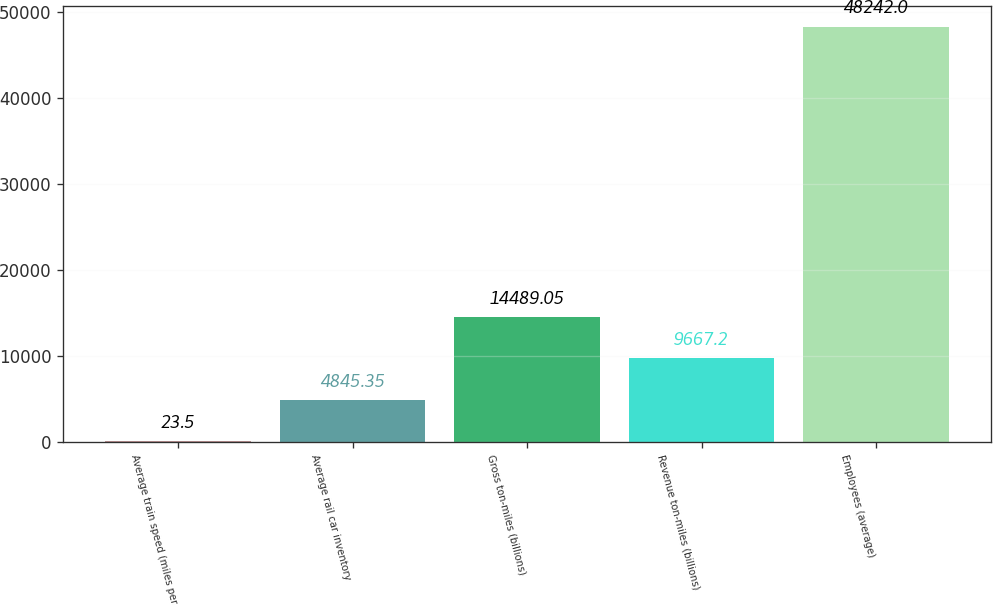<chart> <loc_0><loc_0><loc_500><loc_500><bar_chart><fcel>Average train speed (miles per<fcel>Average rail car inventory<fcel>Gross ton-miles (billions)<fcel>Revenue ton-miles (billions)<fcel>Employees (average)<nl><fcel>23.5<fcel>4845.35<fcel>14489<fcel>9667.2<fcel>48242<nl></chart> 